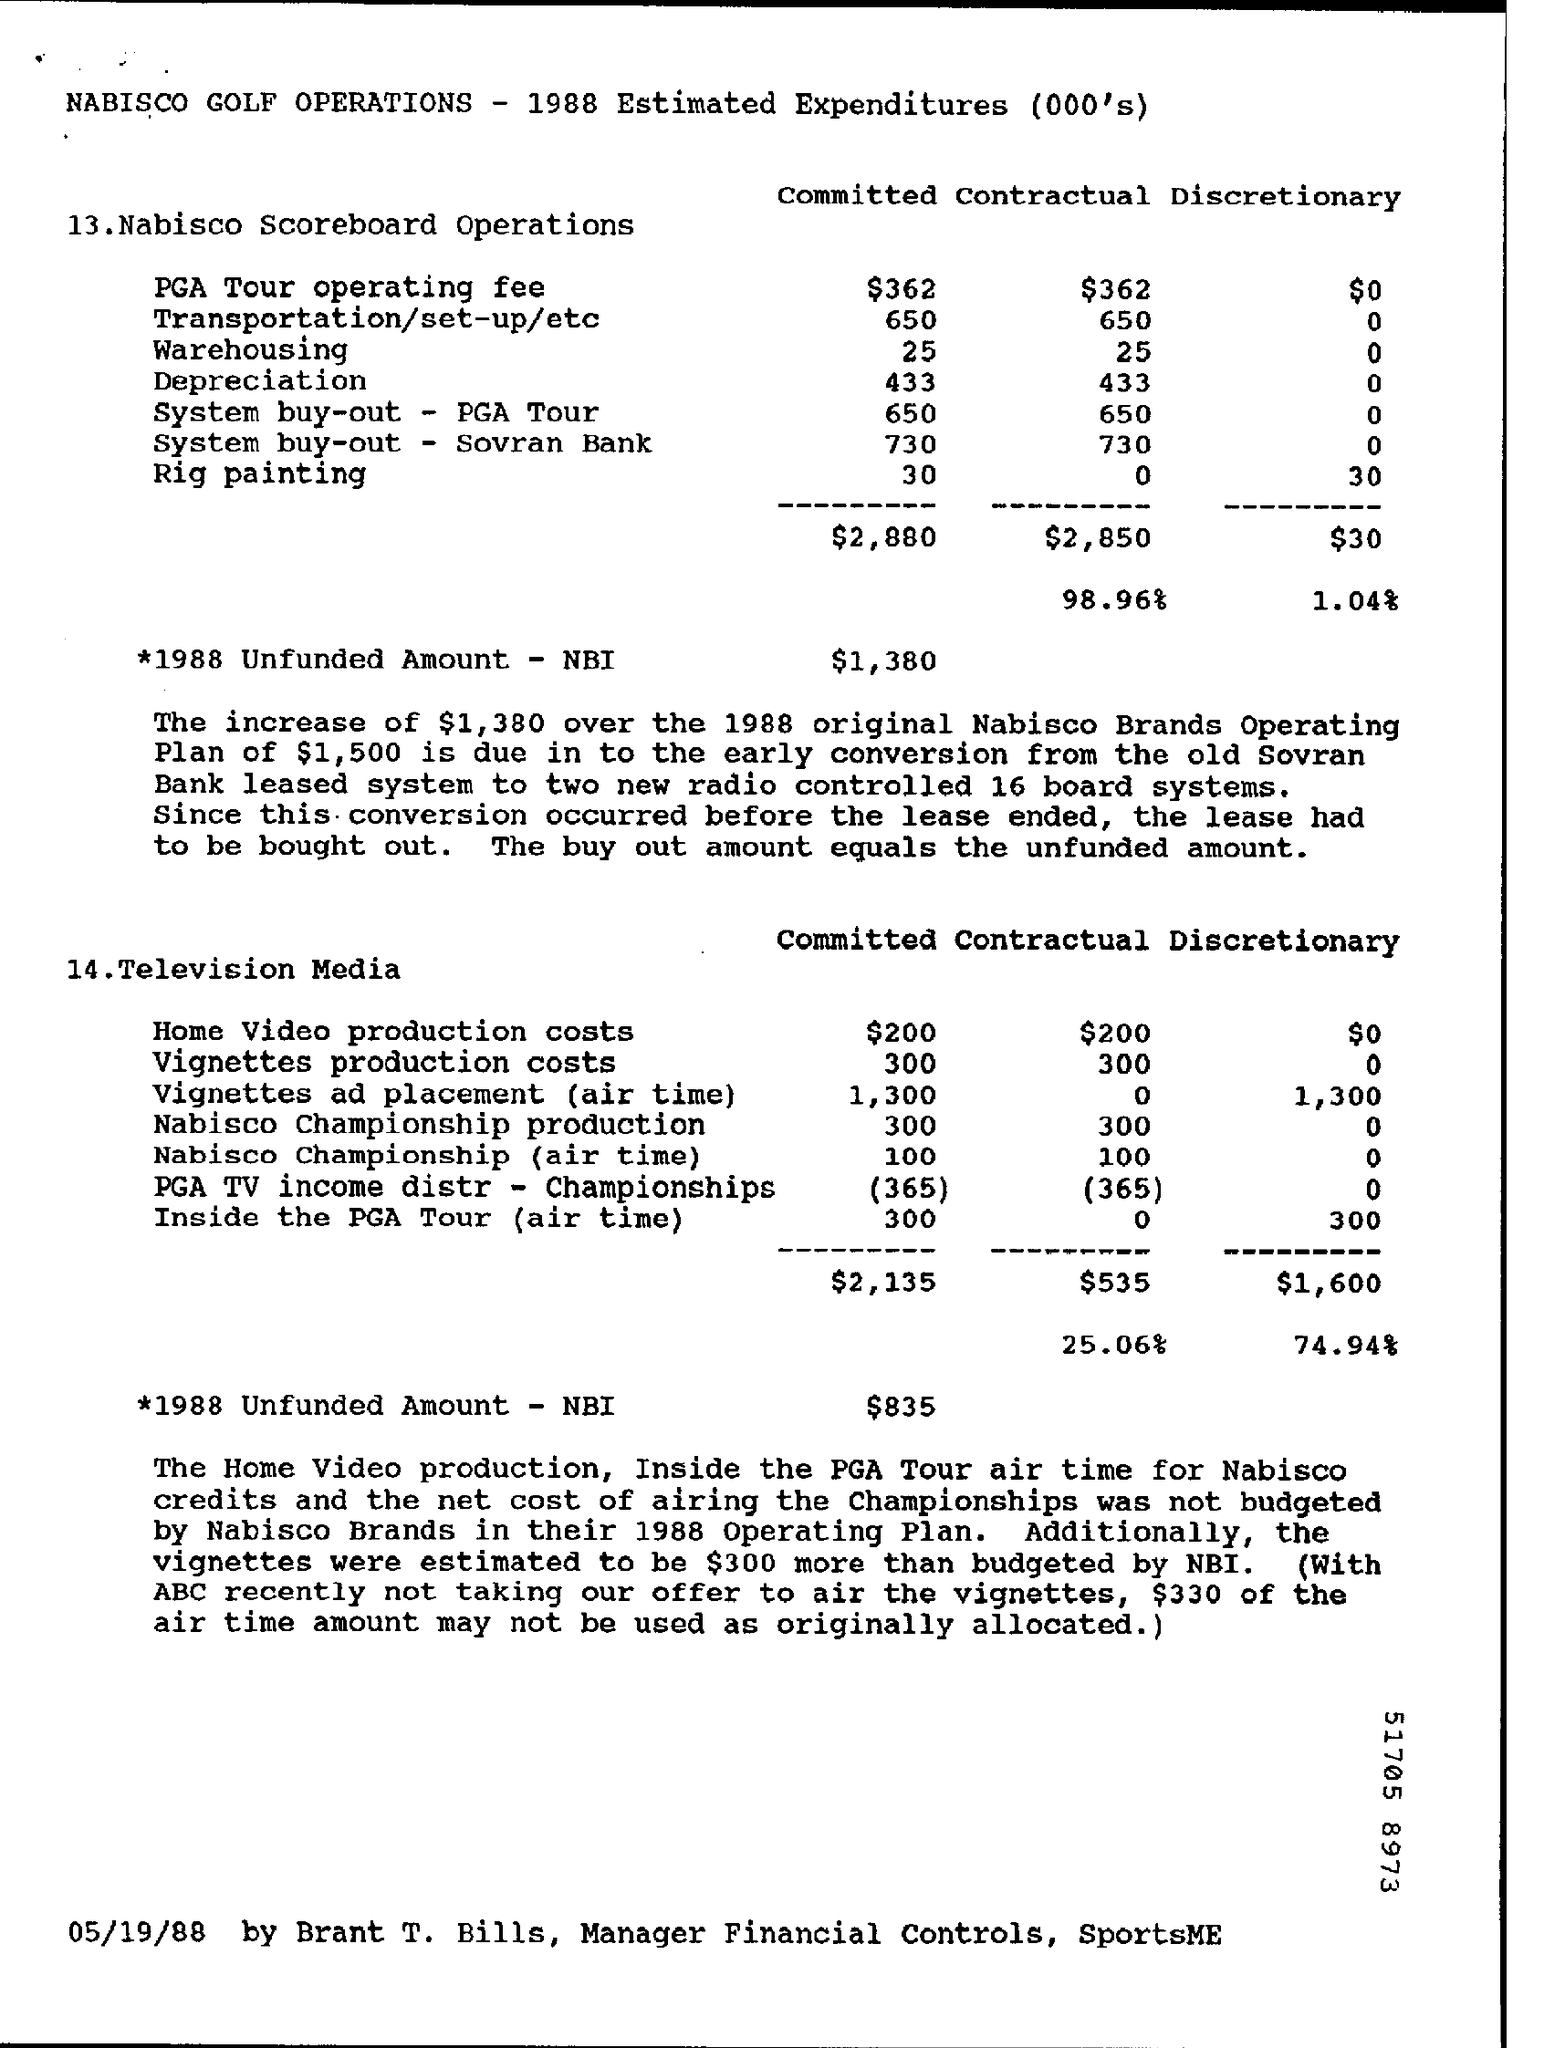Highlight a few significant elements in this photo. The estimated expenditure on contractual vignettes production costs for television media is approximately 300. In 1988, the unfunded amount for Nabisco scoreboard operations was $1,380. The estimated expenditure for contractual rig painting in Nabisco scoreboard operations is [0-]. The estimated expenditure of committed home video production costs in television media is currently $200. Nabisco's estimated committed expenditure for scoreboard operations in warehousing is approximately $25. 